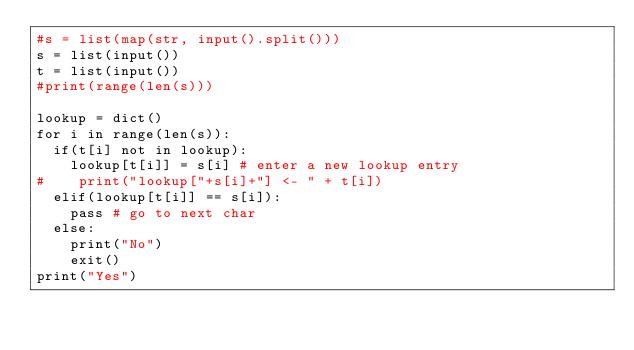<code> <loc_0><loc_0><loc_500><loc_500><_Python_>#s = list(map(str, input().split()))
s = list(input())
t = list(input())
#print(range(len(s)))

lookup = dict()
for i in range(len(s)):
  if(t[i] not in lookup):
    lookup[t[i]] = s[i] # enter a new lookup entry
#    print("lookup["+s[i]+"] <- " + t[i])
  elif(lookup[t[i]] == s[i]):
    pass # go to next char
  else:
    print("No")
    exit()
print("Yes")</code> 